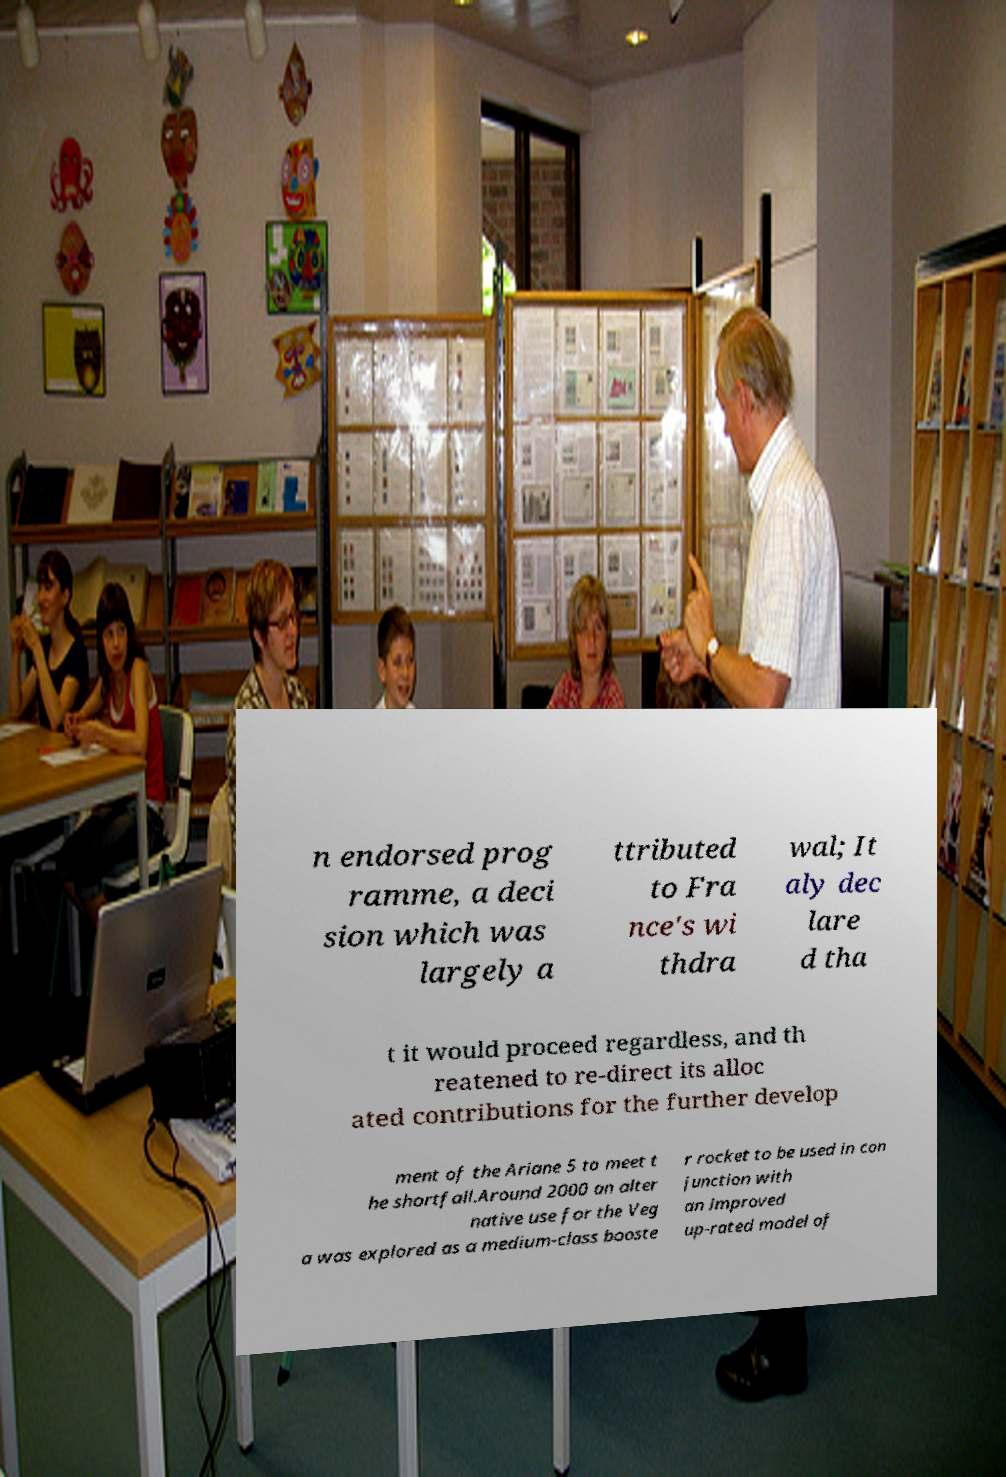Please identify and transcribe the text found in this image. n endorsed prog ramme, a deci sion which was largely a ttributed to Fra nce's wi thdra wal; It aly dec lare d tha t it would proceed regardless, and th reatened to re-direct its alloc ated contributions for the further develop ment of the Ariane 5 to meet t he shortfall.Around 2000 an alter native use for the Veg a was explored as a medium-class booste r rocket to be used in con junction with an improved up-rated model of 